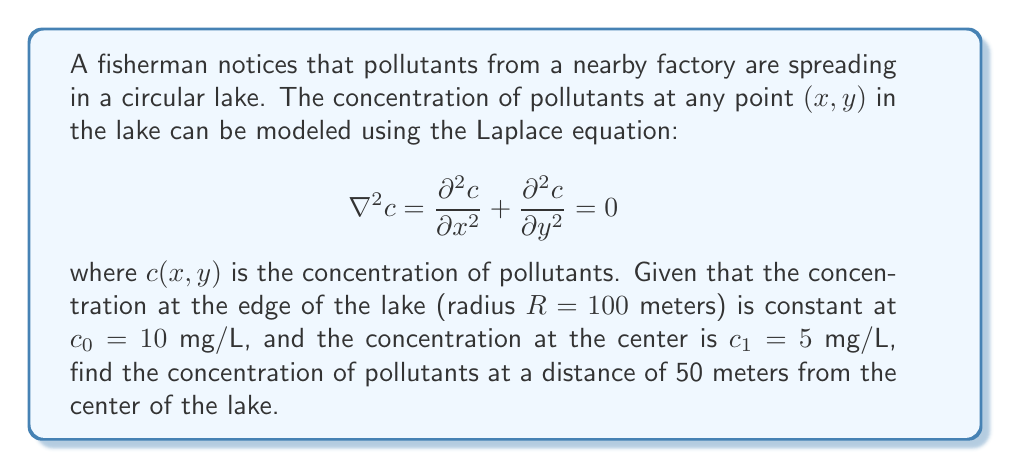Could you help me with this problem? Let's solve this step-by-step:

1) The general solution to the Laplace equation in polar coordinates $(r,\theta)$ for a circular domain with radial symmetry is:

   $$c(r) = A \ln(r) + B$$

   where $A$ and $B$ are constants to be determined from the boundary conditions.

2) We have two boundary conditions:
   - At $r = R = 100$ m, $c = c_0 = 10$ mg/L
   - At $r = 0$ (center), $c = c_1 = 5$ mg/L

3) Applying the first condition:

   $$10 = A \ln(100) + B$$

4) For the second condition, we can't directly use $r = 0$ as $\ln(0)$ is undefined. Instead, we use the fact that the solution must be finite at $r = 0$, which implies $A = 0$. This gives us:

   $$5 = B$$

5) Substituting this back into the equation from step 3:

   $$10 = 0 \cdot \ln(100) + 5$$

   This is consistent with our boundary conditions.

6) Therefore, our solution is:

   $$c(r) = 5 \text{ mg/L}$$

7) This constant solution means that the concentration is the same everywhere in the lake, including at 50 meters from the center.
Answer: 5 mg/L 